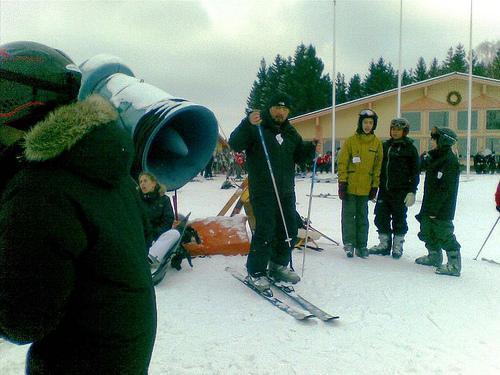How many people are there?
Give a very brief answer. 6. How many zebras are there?
Give a very brief answer. 0. 